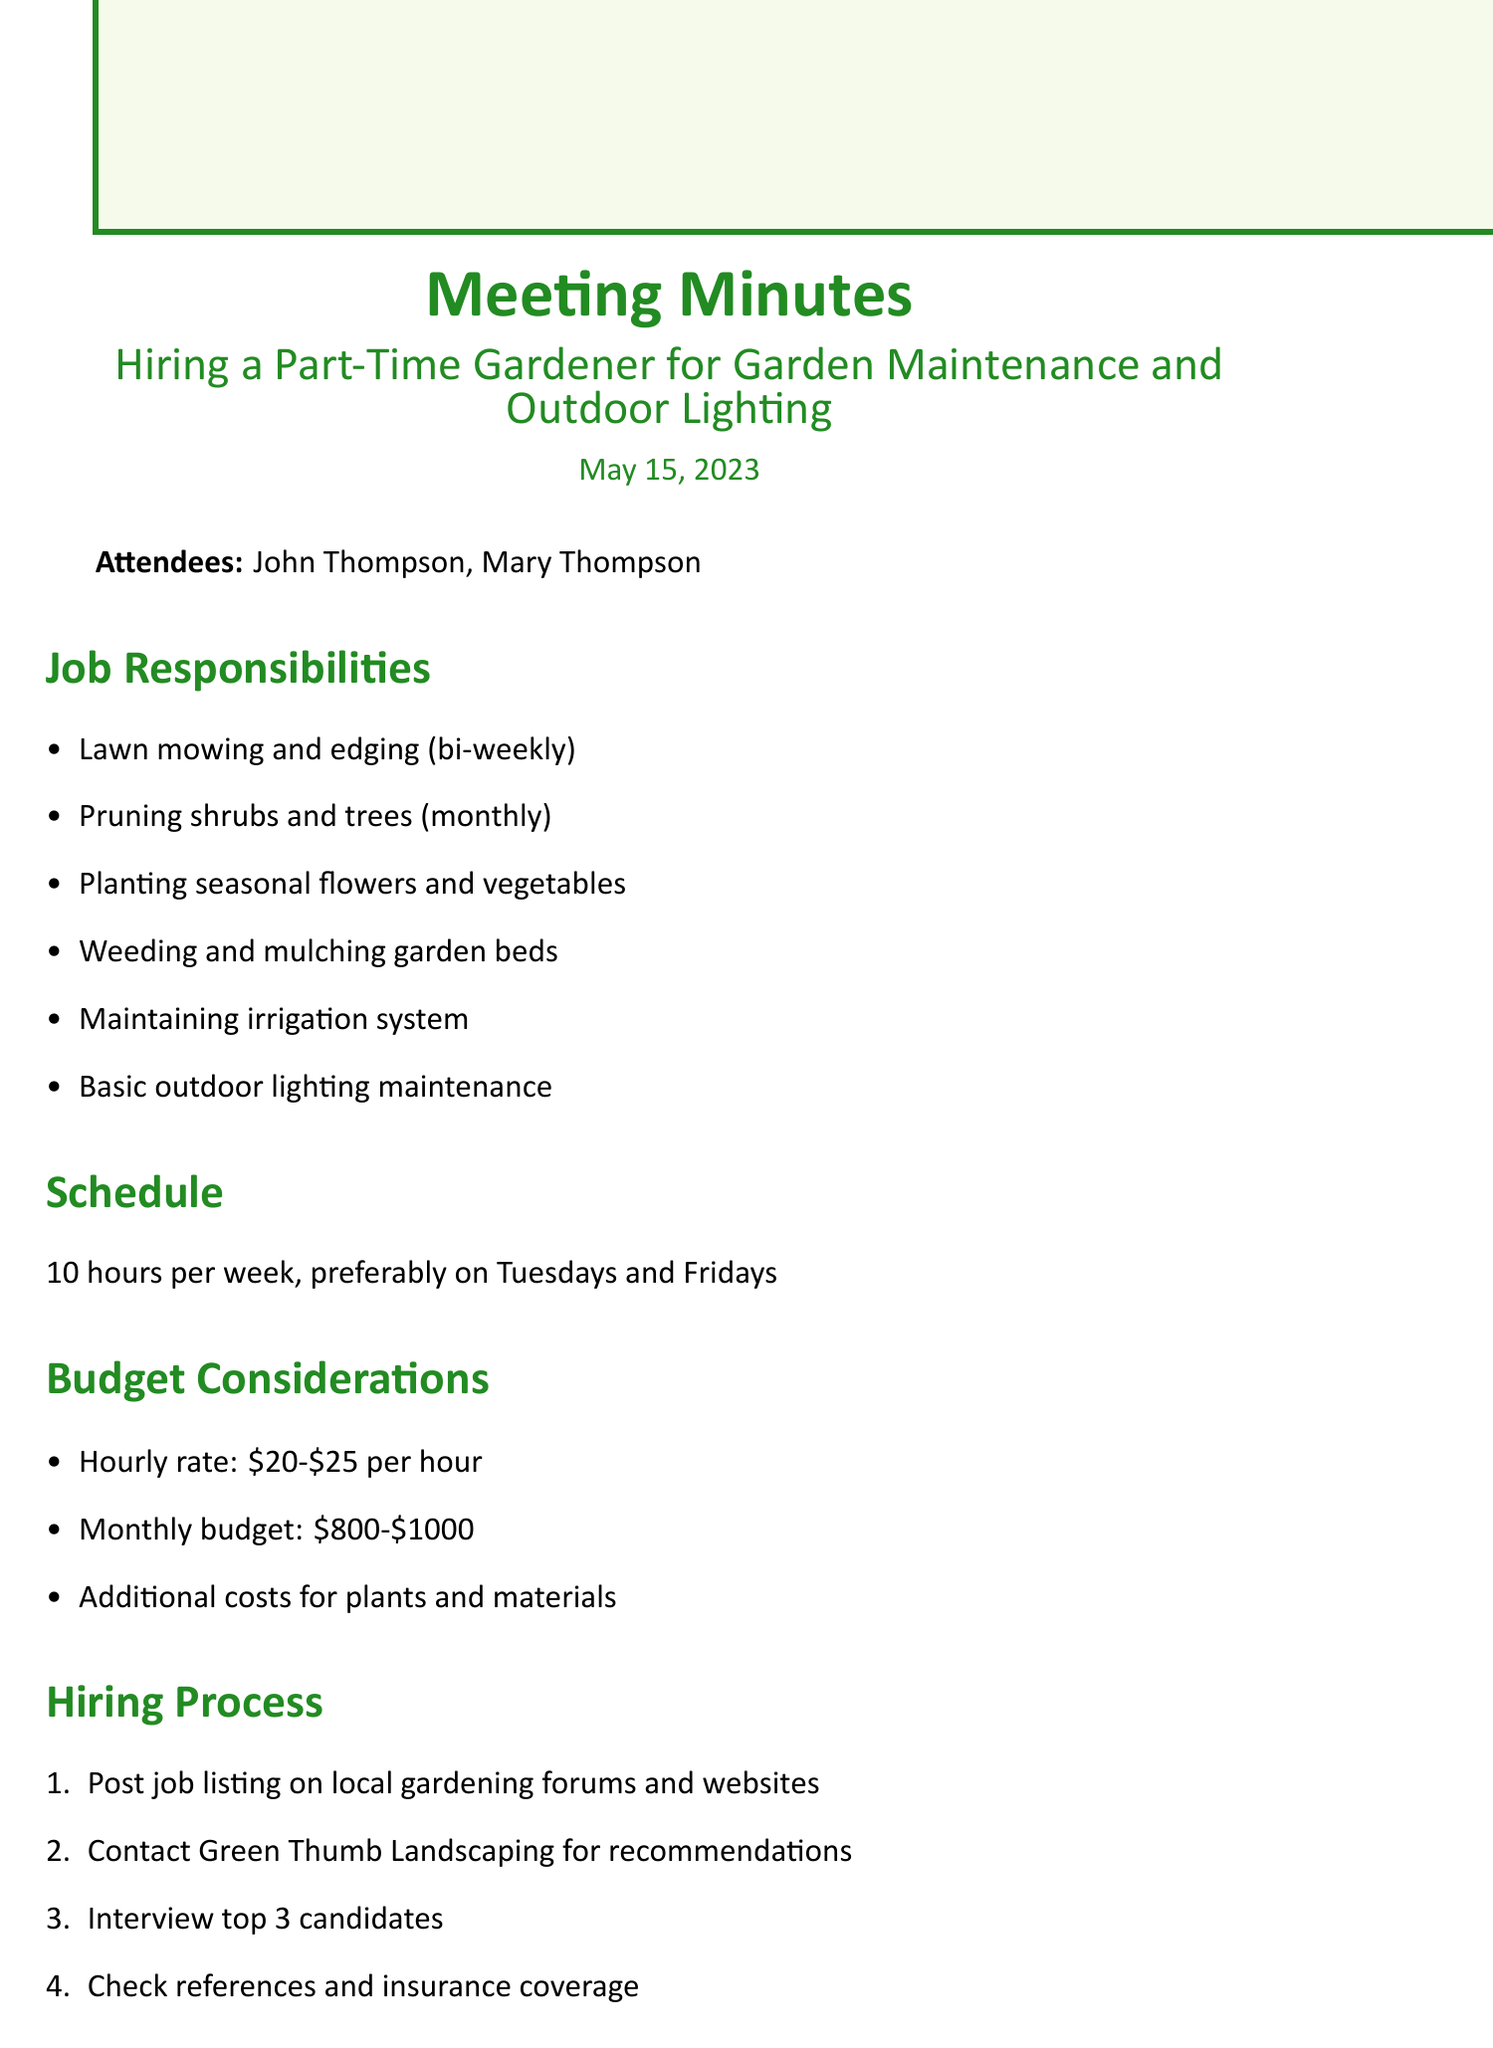What is the hiring date for the gardener? The gardener is to be hired as discussed during the meeting on May 15, 2023, so this is the relevant date for hiring considerations.
Answer: May 15, 2023 How many hours per week is the gardener expected to work? The document specifies a schedule of 10 hours per week for the gardener's work.
Answer: 10 hours What is the monthly budget range for hiring the gardener? The document outlines the budget considerations which mention the monthly budget range as $800 to $1000.
Answer: $800-$1000 Which day is preferably chosen for the gardener's working schedule? The minutes suggest Tuesdays and Fridays as the preferred days for the gardener’s work schedule.
Answer: Tuesdays and Fridays What is the hourly rate for the gardener? The budget section includes the hourly rate, which is specified as ranging from $20 to $25 per hour.
Answer: $20-$25 Who should be contacted for recommendations regarding the gardener? The document states that Green Thumb Landscaping is to be contacted for recommendations during the hiring process.
Answer: Green Thumb Landscaping When is the job posting expected to be drafted? The action item in the minutes notes that the job posting should be drafted by May 20.
Answer: May 20 What type of maintenance is included in outdoor lighting responsibilities? The job responsibilities include basic maintenance tasks like cleaning fixtures and replacing bulbs as part of outdoor lighting care.
Answer: Cleaning fixtures, replacing bulbs What equipment will the gardener use? The document specifies that the gardener will use the couple's lawn mower and basic tools while specialized equipment will be provided by the gardener.
Answer: Our lawn mower and basic tools 